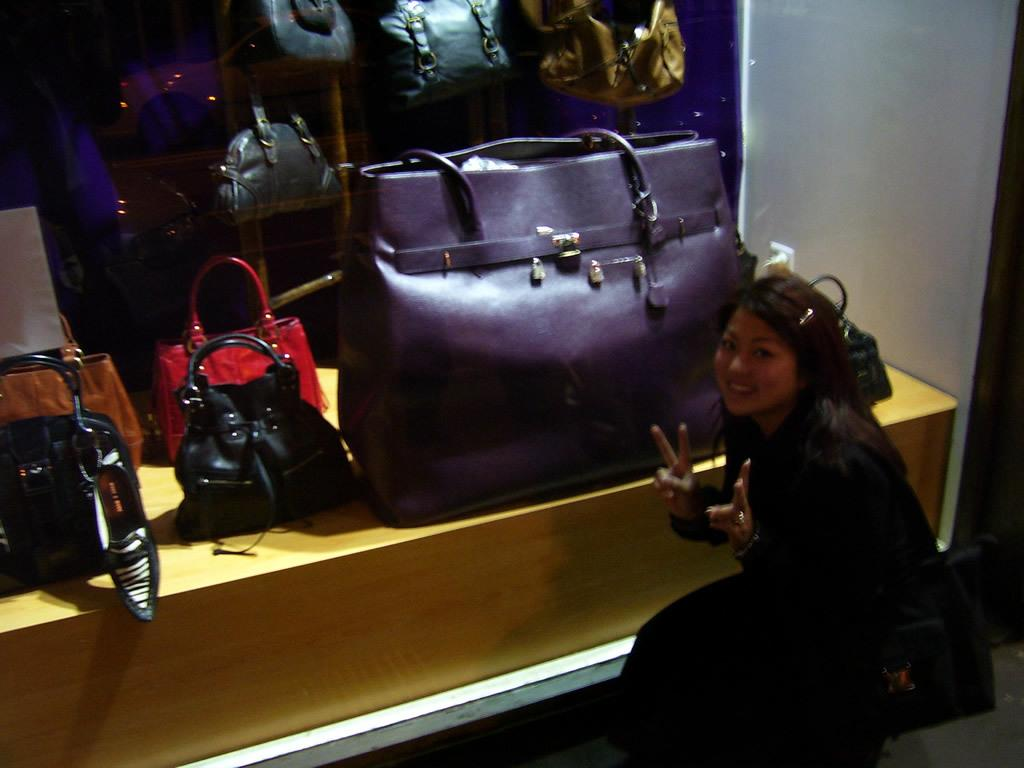Who is present in the image? There is a lady in the image. What is the lady holding in the image? The lady is holding a bag. Can you describe the platform and stand in the image? There is a platform with bags and a stand with bags in the image. What type of rhythm can be heard coming from the pen in the image? There is no pen present in the image, and therefore no rhythm can be heard from it. 